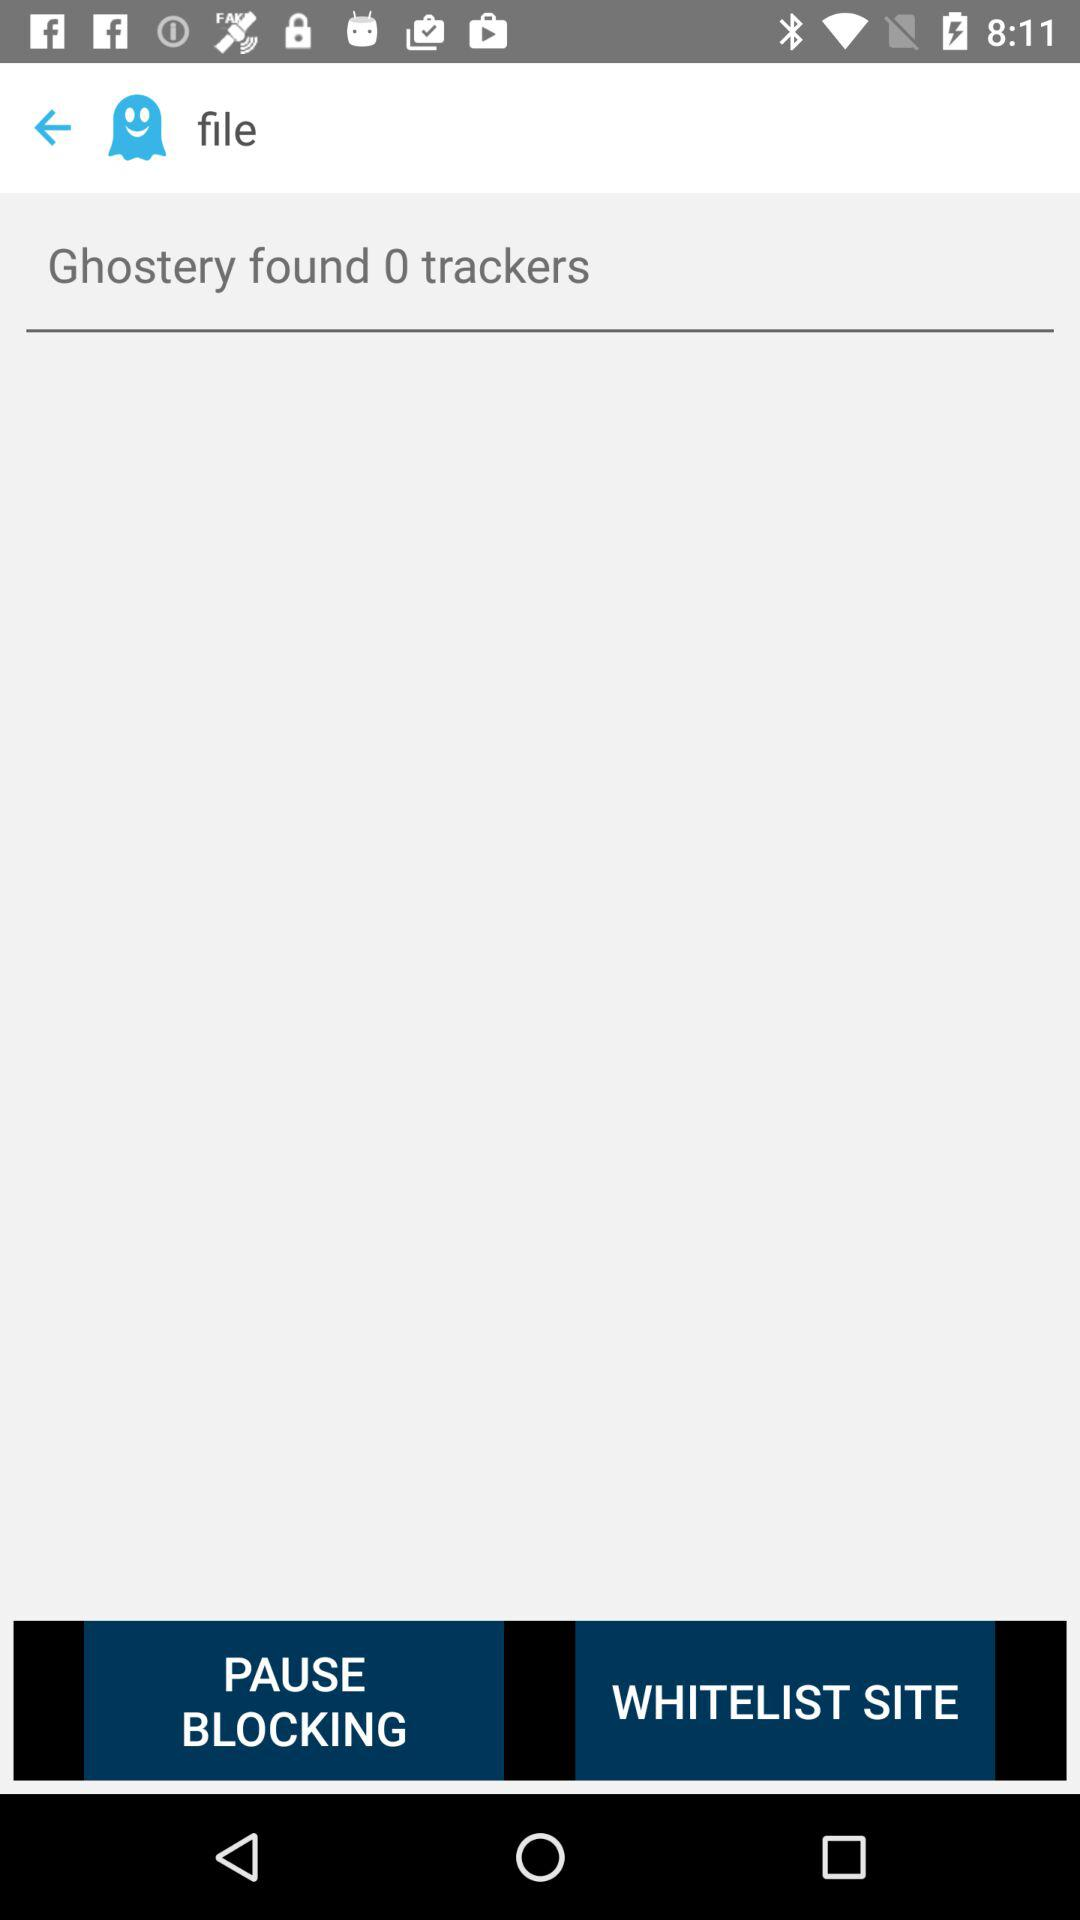How many trackers were found?
Answer the question using a single word or phrase. 0 